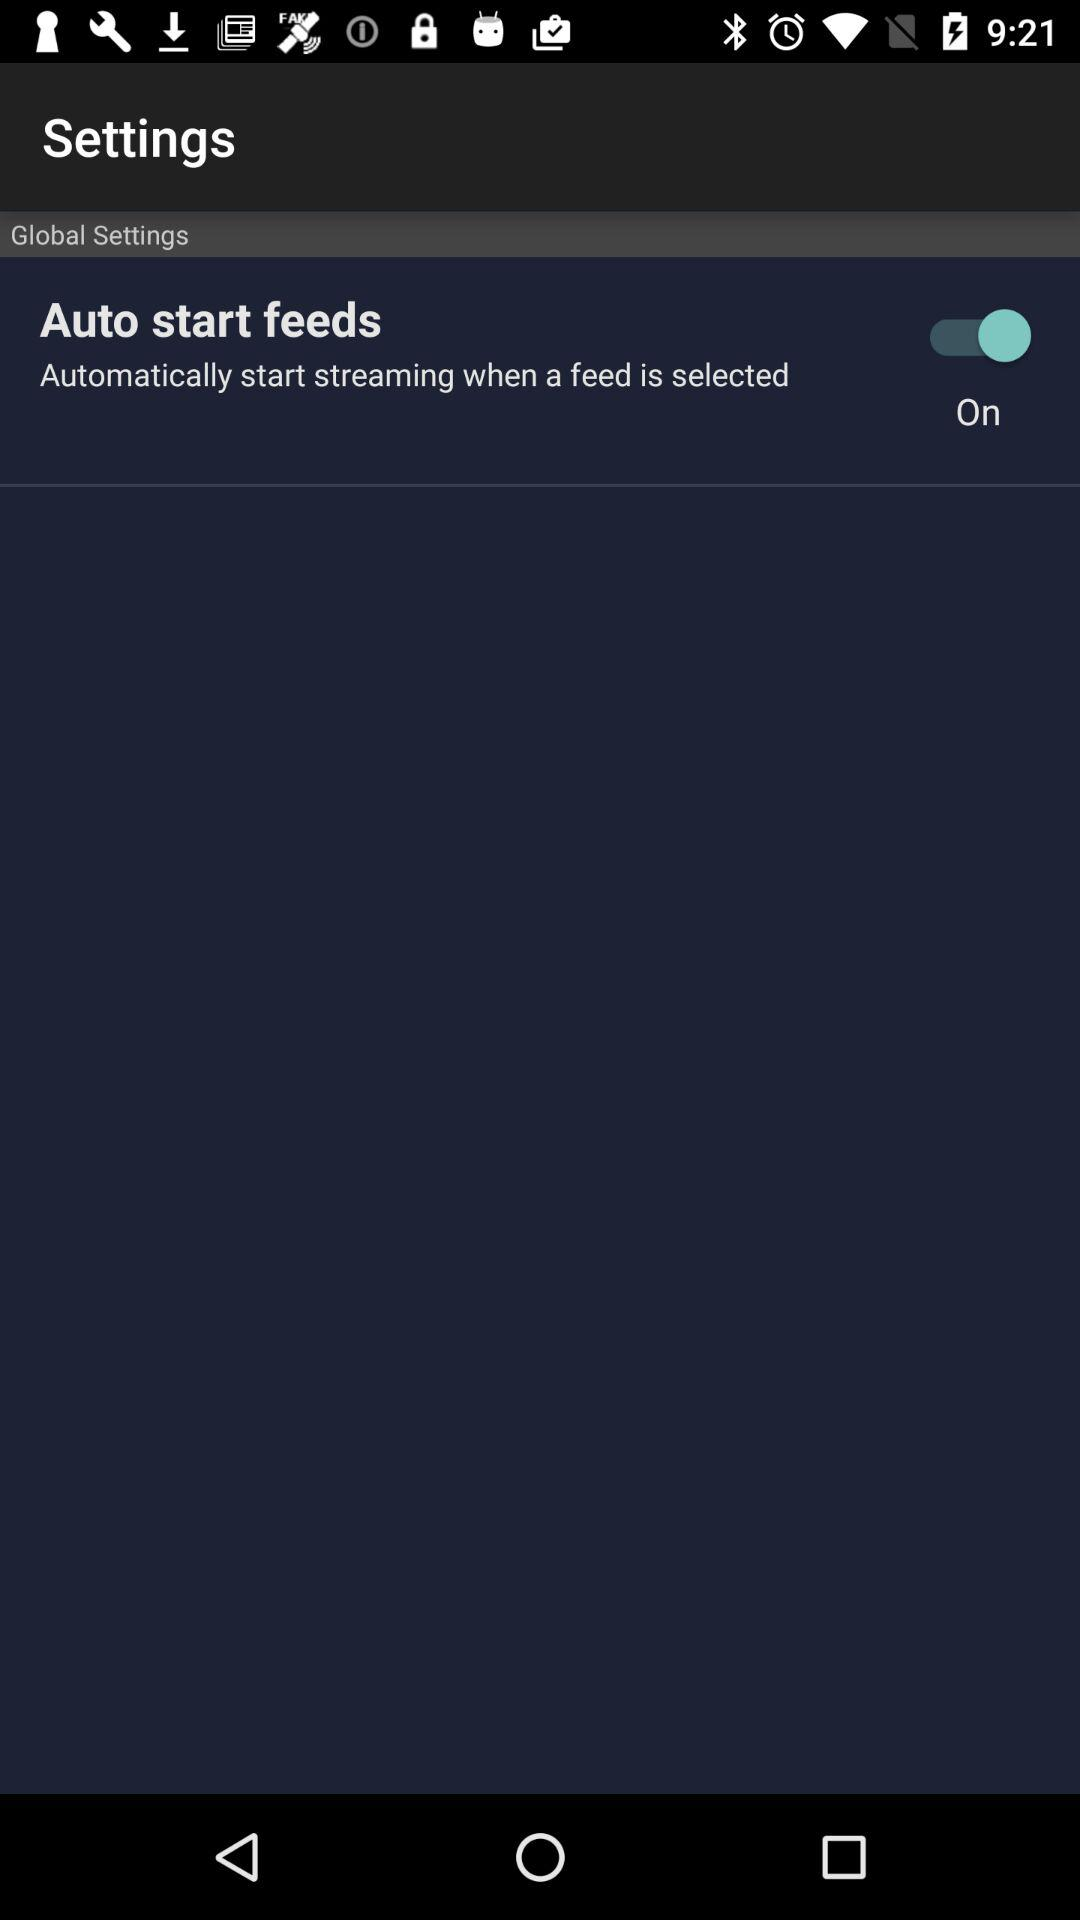What is the name of the application?
When the provided information is insufficient, respond with <no answer>. <no answer> 